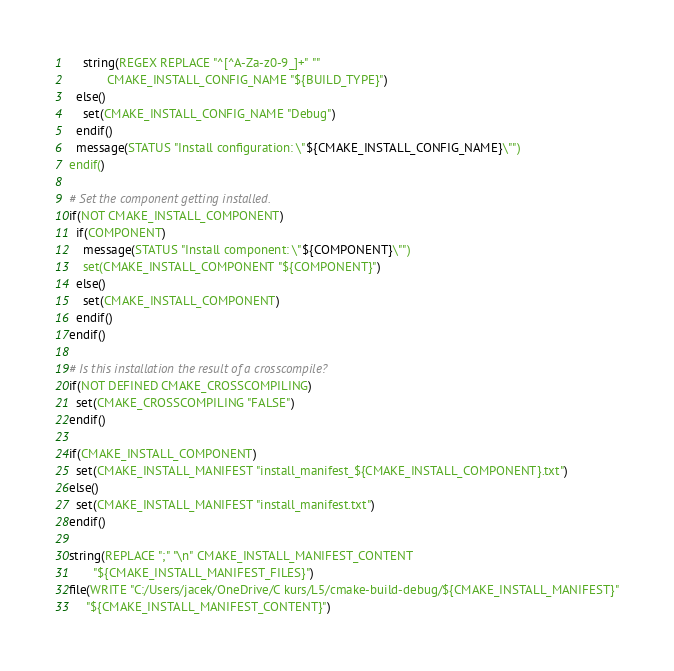Convert code to text. <code><loc_0><loc_0><loc_500><loc_500><_CMake_>    string(REGEX REPLACE "^[^A-Za-z0-9_]+" ""
           CMAKE_INSTALL_CONFIG_NAME "${BUILD_TYPE}")
  else()
    set(CMAKE_INSTALL_CONFIG_NAME "Debug")
  endif()
  message(STATUS "Install configuration: \"${CMAKE_INSTALL_CONFIG_NAME}\"")
endif()

# Set the component getting installed.
if(NOT CMAKE_INSTALL_COMPONENT)
  if(COMPONENT)
    message(STATUS "Install component: \"${COMPONENT}\"")
    set(CMAKE_INSTALL_COMPONENT "${COMPONENT}")
  else()
    set(CMAKE_INSTALL_COMPONENT)
  endif()
endif()

# Is this installation the result of a crosscompile?
if(NOT DEFINED CMAKE_CROSSCOMPILING)
  set(CMAKE_CROSSCOMPILING "FALSE")
endif()

if(CMAKE_INSTALL_COMPONENT)
  set(CMAKE_INSTALL_MANIFEST "install_manifest_${CMAKE_INSTALL_COMPONENT}.txt")
else()
  set(CMAKE_INSTALL_MANIFEST "install_manifest.txt")
endif()

string(REPLACE ";" "\n" CMAKE_INSTALL_MANIFEST_CONTENT
       "${CMAKE_INSTALL_MANIFEST_FILES}")
file(WRITE "C:/Users/jacek/OneDrive/C kurs/L5/cmake-build-debug/${CMAKE_INSTALL_MANIFEST}"
     "${CMAKE_INSTALL_MANIFEST_CONTENT}")
</code> 